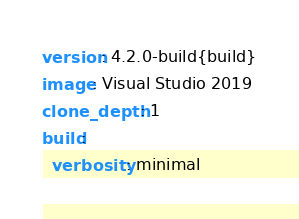Convert code to text. <code><loc_0><loc_0><loc_500><loc_500><_YAML_>version: 4.2.0-build{build}
image: Visual Studio 2019
clone_depth: 1
build:
  verbosity: minimal
</code> 